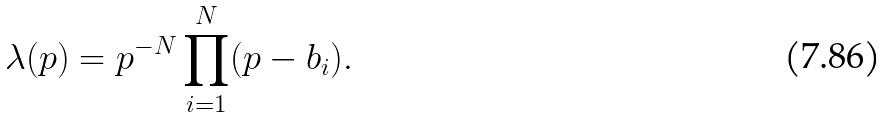Convert formula to latex. <formula><loc_0><loc_0><loc_500><loc_500>\lambda ( p ) = p ^ { - N } \prod _ { i = 1 } ^ { N } ( p - b _ { i } ) .</formula> 